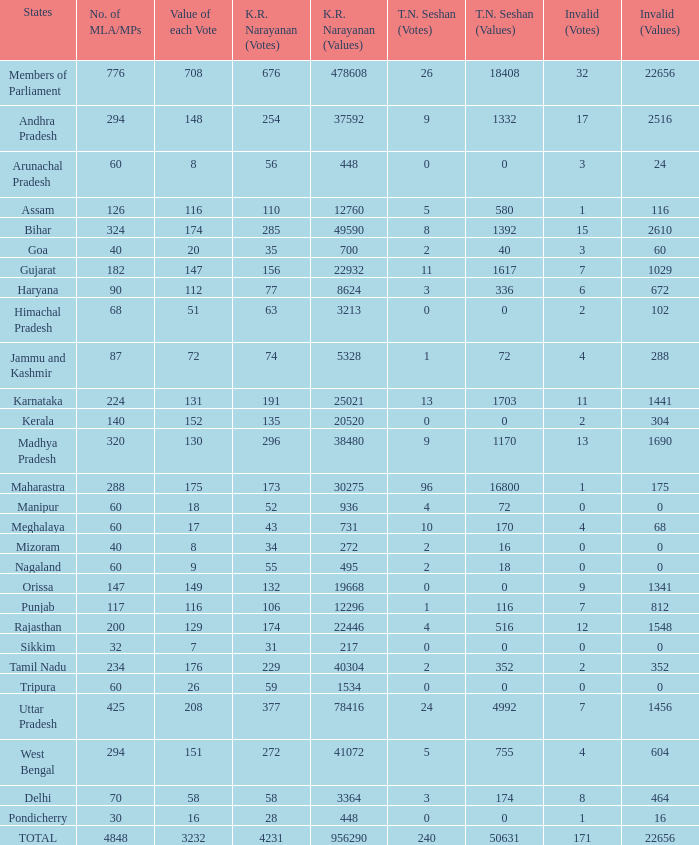Name the k. r. narayanan values for pondicherry 448.0. 